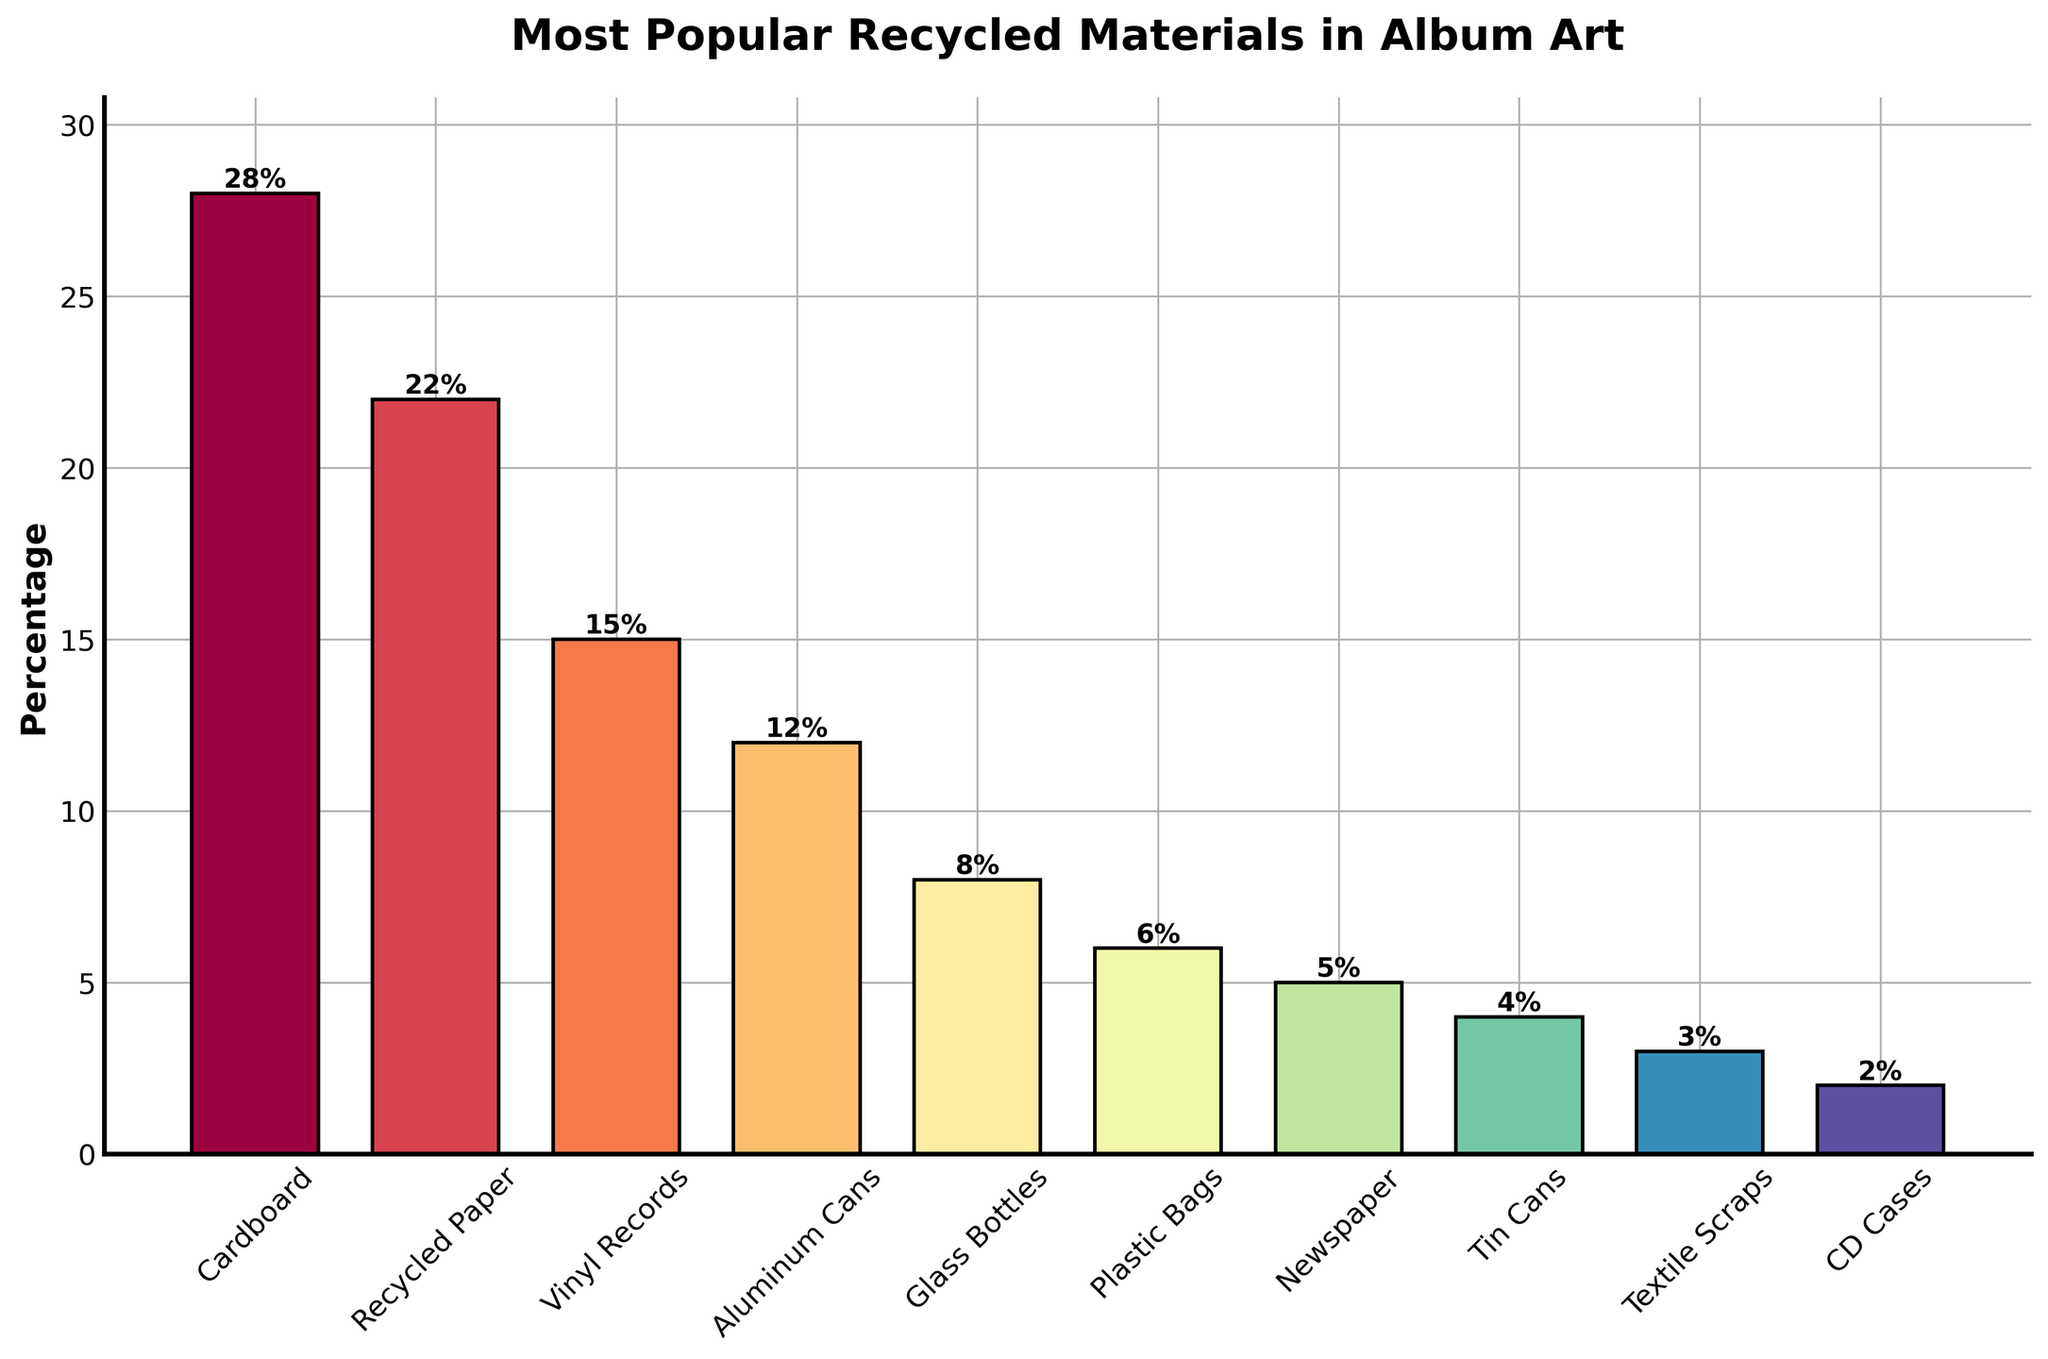Which material is the most popular for recycled album art? The figure's title is "Most Popular Recycled Materials in Album Art", and the tallest bar represents "Cardboard" with a percentage of 28%.
Answer: Cardboard What is the difference in popularity between Cardboard and Vinyl Records? Cardboard has a percentage of 28% and Vinyl Records have 15%. The difference is calculated as 28% - 15% = 13%.
Answer: 13% Which material, Plastic Bags or Newspaper, is more popular for recycled album art? By comparing the height of the bars, Plastic Bags have a percentage of 6% while Newspaper has 5%. Plastic Bags are slightly more popular.
Answer: Plastic Bags What is the combined percentage of Recycled Paper and Glass Bottles used in album art? Recycled Paper has a percentage of 22% and Glass Bottles have 8%. Adding these together gives 22% + 8% = 30%.
Answer: 30% Rank the materials Aluminum Cans, Plastic Bags, and Textile Scraps in order of popularity. Aluminum Cans have 12%, Plastic Bags have 6%, and Textile Scraps have 3%. Ranking them in descending order: Aluminum Cans, Plastic Bags, Textile Scraps.
Answer: Aluminum Cans, Plastic Bags, Textile Scraps Which two materials have the closest percentages, and what are their values? By comparing the bar heights, Plastic Bags (6%) and Newspaper (5%) have the closest percentages, differing by only 1%.
Answer: Plastic Bags and Newspaper with 6% and 5% What is the total percentage for materials that have a popularity below 10%? Adding the percentages for Glass Bottles (8%), Plastic Bags (6%), Newspaper (5%), Tin Cans (4%), Textile Scraps (3%), and CD Cases (2%) gives 8% + 6% + 5% + 4% + 3% + 2% = 28%.
Answer: 28% If you combine Cardboard, Recycled Paper, and Newspaper, what percentage of album art uses these materials? Cardboard has 28%, Recycled Paper has 22%, and Newspaper has 5%. Their combined percentage is 28% + 22% + 5% = 55%.
Answer: 55% Which color bar corresponds to the material with the least popularity? The material with the least popularity is CD Cases with 2%. The bar representing CD Cases, shown in the figure, will have a unique color different from other bars.
Answer: The color of the bar representing CD Cases, which visually stands out in the plot 